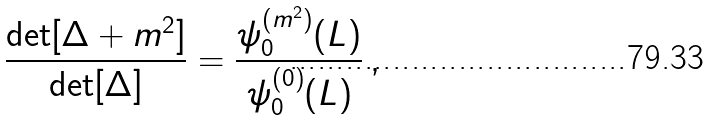Convert formula to latex. <formula><loc_0><loc_0><loc_500><loc_500>\frac { \det [ \Delta + m ^ { 2 } ] } { \det [ \Delta ] } = \frac { \psi ^ { ( m ^ { 2 } ) } _ { 0 } ( L ) } { \psi ^ { ( 0 ) } _ { 0 } ( L ) } \, ,</formula> 